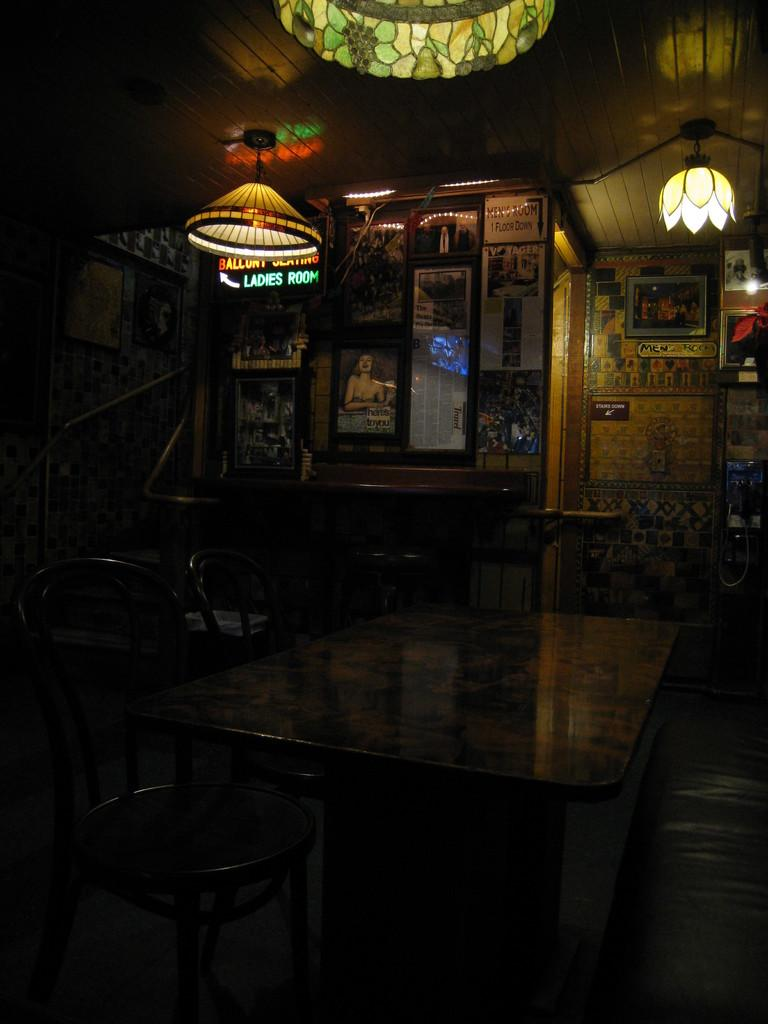What type of furniture is present in the image? There is a table and chairs in the image. What type of lighting is present in the image? There are lamps and a chandelier in the image. What is hanging on the wall in the image? There are frames on the wall in the image. What part of the room is visible in the image? The roof is visible in the image. Can you describe any other objects in the image? There are some objects in the image, but their specific details are not mentioned in the provided facts. What type of crime is being committed in the image? There is no indication of any crime being committed in the image. Can you see any ducks in the image? There are no ducks present in the image. 